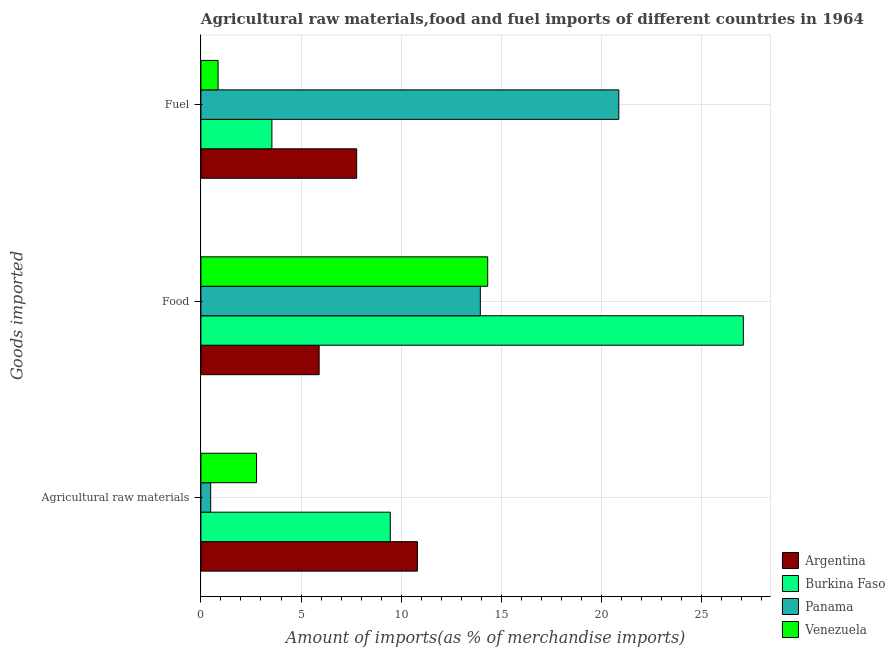How many different coloured bars are there?
Provide a succinct answer. 4. Are the number of bars on each tick of the Y-axis equal?
Your answer should be compact. Yes. What is the label of the 1st group of bars from the top?
Ensure brevity in your answer.  Fuel. What is the percentage of raw materials imports in Argentina?
Your answer should be compact. 10.81. Across all countries, what is the maximum percentage of raw materials imports?
Your answer should be very brief. 10.81. Across all countries, what is the minimum percentage of fuel imports?
Ensure brevity in your answer.  0.86. In which country was the percentage of fuel imports maximum?
Your answer should be very brief. Panama. In which country was the percentage of raw materials imports minimum?
Give a very brief answer. Panama. What is the total percentage of fuel imports in the graph?
Your answer should be compact. 33.06. What is the difference between the percentage of food imports in Panama and that in Burkina Faso?
Give a very brief answer. -13.14. What is the difference between the percentage of fuel imports in Panama and the percentage of raw materials imports in Venezuela?
Your response must be concise. 18.09. What is the average percentage of fuel imports per country?
Give a very brief answer. 8.26. What is the difference between the percentage of raw materials imports and percentage of fuel imports in Argentina?
Your answer should be compact. 3.03. In how many countries, is the percentage of raw materials imports greater than 5 %?
Make the answer very short. 2. What is the ratio of the percentage of raw materials imports in Venezuela to that in Panama?
Your response must be concise. 5.71. Is the difference between the percentage of raw materials imports in Burkina Faso and Venezuela greater than the difference between the percentage of fuel imports in Burkina Faso and Venezuela?
Make the answer very short. Yes. What is the difference between the highest and the second highest percentage of raw materials imports?
Your answer should be compact. 1.36. What is the difference between the highest and the lowest percentage of food imports?
Give a very brief answer. 21.19. In how many countries, is the percentage of food imports greater than the average percentage of food imports taken over all countries?
Offer a very short reply. 1. Is the sum of the percentage of fuel imports in Venezuela and Panama greater than the maximum percentage of food imports across all countries?
Provide a succinct answer. No. What does the 4th bar from the top in Agricultural raw materials represents?
Make the answer very short. Argentina. What does the 4th bar from the bottom in Fuel represents?
Provide a short and direct response. Venezuela. Are all the bars in the graph horizontal?
Offer a very short reply. Yes. Does the graph contain grids?
Keep it short and to the point. Yes. Where does the legend appear in the graph?
Your response must be concise. Bottom right. How many legend labels are there?
Offer a very short reply. 4. What is the title of the graph?
Your response must be concise. Agricultural raw materials,food and fuel imports of different countries in 1964. Does "Sierra Leone" appear as one of the legend labels in the graph?
Make the answer very short. No. What is the label or title of the X-axis?
Offer a terse response. Amount of imports(as % of merchandise imports). What is the label or title of the Y-axis?
Give a very brief answer. Goods imported. What is the Amount of imports(as % of merchandise imports) in Argentina in Agricultural raw materials?
Your answer should be very brief. 10.81. What is the Amount of imports(as % of merchandise imports) in Burkina Faso in Agricultural raw materials?
Your answer should be compact. 9.46. What is the Amount of imports(as % of merchandise imports) of Panama in Agricultural raw materials?
Your answer should be very brief. 0.49. What is the Amount of imports(as % of merchandise imports) in Venezuela in Agricultural raw materials?
Provide a succinct answer. 2.78. What is the Amount of imports(as % of merchandise imports) of Argentina in Food?
Offer a very short reply. 5.91. What is the Amount of imports(as % of merchandise imports) of Burkina Faso in Food?
Ensure brevity in your answer.  27.09. What is the Amount of imports(as % of merchandise imports) of Panama in Food?
Your answer should be compact. 13.96. What is the Amount of imports(as % of merchandise imports) in Venezuela in Food?
Make the answer very short. 14.32. What is the Amount of imports(as % of merchandise imports) in Argentina in Fuel?
Offer a terse response. 7.78. What is the Amount of imports(as % of merchandise imports) of Burkina Faso in Fuel?
Provide a short and direct response. 3.54. What is the Amount of imports(as % of merchandise imports) of Panama in Fuel?
Offer a very short reply. 20.87. What is the Amount of imports(as % of merchandise imports) of Venezuela in Fuel?
Your answer should be very brief. 0.86. Across all Goods imported, what is the maximum Amount of imports(as % of merchandise imports) in Argentina?
Offer a very short reply. 10.81. Across all Goods imported, what is the maximum Amount of imports(as % of merchandise imports) in Burkina Faso?
Your answer should be compact. 27.09. Across all Goods imported, what is the maximum Amount of imports(as % of merchandise imports) of Panama?
Your answer should be very brief. 20.87. Across all Goods imported, what is the maximum Amount of imports(as % of merchandise imports) of Venezuela?
Your response must be concise. 14.32. Across all Goods imported, what is the minimum Amount of imports(as % of merchandise imports) in Argentina?
Provide a succinct answer. 5.91. Across all Goods imported, what is the minimum Amount of imports(as % of merchandise imports) of Burkina Faso?
Make the answer very short. 3.54. Across all Goods imported, what is the minimum Amount of imports(as % of merchandise imports) in Panama?
Ensure brevity in your answer.  0.49. Across all Goods imported, what is the minimum Amount of imports(as % of merchandise imports) of Venezuela?
Your answer should be compact. 0.86. What is the total Amount of imports(as % of merchandise imports) of Argentina in the graph?
Keep it short and to the point. 24.5. What is the total Amount of imports(as % of merchandise imports) of Burkina Faso in the graph?
Provide a succinct answer. 40.09. What is the total Amount of imports(as % of merchandise imports) in Panama in the graph?
Make the answer very short. 35.32. What is the total Amount of imports(as % of merchandise imports) of Venezuela in the graph?
Your response must be concise. 17.96. What is the difference between the Amount of imports(as % of merchandise imports) in Argentina in Agricultural raw materials and that in Food?
Provide a short and direct response. 4.91. What is the difference between the Amount of imports(as % of merchandise imports) of Burkina Faso in Agricultural raw materials and that in Food?
Your answer should be very brief. -17.63. What is the difference between the Amount of imports(as % of merchandise imports) of Panama in Agricultural raw materials and that in Food?
Offer a terse response. -13.47. What is the difference between the Amount of imports(as % of merchandise imports) of Venezuela in Agricultural raw materials and that in Food?
Make the answer very short. -11.55. What is the difference between the Amount of imports(as % of merchandise imports) of Argentina in Agricultural raw materials and that in Fuel?
Give a very brief answer. 3.03. What is the difference between the Amount of imports(as % of merchandise imports) in Burkina Faso in Agricultural raw materials and that in Fuel?
Offer a very short reply. 5.91. What is the difference between the Amount of imports(as % of merchandise imports) of Panama in Agricultural raw materials and that in Fuel?
Keep it short and to the point. -20.39. What is the difference between the Amount of imports(as % of merchandise imports) of Venezuela in Agricultural raw materials and that in Fuel?
Your response must be concise. 1.92. What is the difference between the Amount of imports(as % of merchandise imports) in Argentina in Food and that in Fuel?
Ensure brevity in your answer.  -1.87. What is the difference between the Amount of imports(as % of merchandise imports) in Burkina Faso in Food and that in Fuel?
Make the answer very short. 23.55. What is the difference between the Amount of imports(as % of merchandise imports) in Panama in Food and that in Fuel?
Offer a very short reply. -6.92. What is the difference between the Amount of imports(as % of merchandise imports) in Venezuela in Food and that in Fuel?
Give a very brief answer. 13.47. What is the difference between the Amount of imports(as % of merchandise imports) in Argentina in Agricultural raw materials and the Amount of imports(as % of merchandise imports) in Burkina Faso in Food?
Your answer should be compact. -16.28. What is the difference between the Amount of imports(as % of merchandise imports) of Argentina in Agricultural raw materials and the Amount of imports(as % of merchandise imports) of Panama in Food?
Make the answer very short. -3.14. What is the difference between the Amount of imports(as % of merchandise imports) of Argentina in Agricultural raw materials and the Amount of imports(as % of merchandise imports) of Venezuela in Food?
Offer a terse response. -3.51. What is the difference between the Amount of imports(as % of merchandise imports) of Burkina Faso in Agricultural raw materials and the Amount of imports(as % of merchandise imports) of Panama in Food?
Make the answer very short. -4.5. What is the difference between the Amount of imports(as % of merchandise imports) in Burkina Faso in Agricultural raw materials and the Amount of imports(as % of merchandise imports) in Venezuela in Food?
Your answer should be very brief. -4.87. What is the difference between the Amount of imports(as % of merchandise imports) in Panama in Agricultural raw materials and the Amount of imports(as % of merchandise imports) in Venezuela in Food?
Your answer should be compact. -13.84. What is the difference between the Amount of imports(as % of merchandise imports) in Argentina in Agricultural raw materials and the Amount of imports(as % of merchandise imports) in Burkina Faso in Fuel?
Offer a terse response. 7.27. What is the difference between the Amount of imports(as % of merchandise imports) in Argentina in Agricultural raw materials and the Amount of imports(as % of merchandise imports) in Panama in Fuel?
Offer a very short reply. -10.06. What is the difference between the Amount of imports(as % of merchandise imports) of Argentina in Agricultural raw materials and the Amount of imports(as % of merchandise imports) of Venezuela in Fuel?
Keep it short and to the point. 9.95. What is the difference between the Amount of imports(as % of merchandise imports) in Burkina Faso in Agricultural raw materials and the Amount of imports(as % of merchandise imports) in Panama in Fuel?
Provide a short and direct response. -11.42. What is the difference between the Amount of imports(as % of merchandise imports) in Burkina Faso in Agricultural raw materials and the Amount of imports(as % of merchandise imports) in Venezuela in Fuel?
Your answer should be very brief. 8.6. What is the difference between the Amount of imports(as % of merchandise imports) of Panama in Agricultural raw materials and the Amount of imports(as % of merchandise imports) of Venezuela in Fuel?
Your answer should be very brief. -0.37. What is the difference between the Amount of imports(as % of merchandise imports) of Argentina in Food and the Amount of imports(as % of merchandise imports) of Burkina Faso in Fuel?
Offer a very short reply. 2.36. What is the difference between the Amount of imports(as % of merchandise imports) of Argentina in Food and the Amount of imports(as % of merchandise imports) of Panama in Fuel?
Offer a terse response. -14.97. What is the difference between the Amount of imports(as % of merchandise imports) in Argentina in Food and the Amount of imports(as % of merchandise imports) in Venezuela in Fuel?
Keep it short and to the point. 5.05. What is the difference between the Amount of imports(as % of merchandise imports) of Burkina Faso in Food and the Amount of imports(as % of merchandise imports) of Panama in Fuel?
Provide a short and direct response. 6.22. What is the difference between the Amount of imports(as % of merchandise imports) in Burkina Faso in Food and the Amount of imports(as % of merchandise imports) in Venezuela in Fuel?
Your answer should be very brief. 26.23. What is the difference between the Amount of imports(as % of merchandise imports) of Panama in Food and the Amount of imports(as % of merchandise imports) of Venezuela in Fuel?
Your response must be concise. 13.1. What is the average Amount of imports(as % of merchandise imports) of Argentina per Goods imported?
Your response must be concise. 8.17. What is the average Amount of imports(as % of merchandise imports) of Burkina Faso per Goods imported?
Give a very brief answer. 13.36. What is the average Amount of imports(as % of merchandise imports) of Panama per Goods imported?
Your response must be concise. 11.77. What is the average Amount of imports(as % of merchandise imports) in Venezuela per Goods imported?
Provide a short and direct response. 5.99. What is the difference between the Amount of imports(as % of merchandise imports) of Argentina and Amount of imports(as % of merchandise imports) of Burkina Faso in Agricultural raw materials?
Keep it short and to the point. 1.36. What is the difference between the Amount of imports(as % of merchandise imports) in Argentina and Amount of imports(as % of merchandise imports) in Panama in Agricultural raw materials?
Offer a very short reply. 10.33. What is the difference between the Amount of imports(as % of merchandise imports) in Argentina and Amount of imports(as % of merchandise imports) in Venezuela in Agricultural raw materials?
Give a very brief answer. 8.03. What is the difference between the Amount of imports(as % of merchandise imports) of Burkina Faso and Amount of imports(as % of merchandise imports) of Panama in Agricultural raw materials?
Give a very brief answer. 8.97. What is the difference between the Amount of imports(as % of merchandise imports) in Burkina Faso and Amount of imports(as % of merchandise imports) in Venezuela in Agricultural raw materials?
Ensure brevity in your answer.  6.68. What is the difference between the Amount of imports(as % of merchandise imports) of Panama and Amount of imports(as % of merchandise imports) of Venezuela in Agricultural raw materials?
Ensure brevity in your answer.  -2.29. What is the difference between the Amount of imports(as % of merchandise imports) in Argentina and Amount of imports(as % of merchandise imports) in Burkina Faso in Food?
Your answer should be compact. -21.19. What is the difference between the Amount of imports(as % of merchandise imports) in Argentina and Amount of imports(as % of merchandise imports) in Panama in Food?
Give a very brief answer. -8.05. What is the difference between the Amount of imports(as % of merchandise imports) in Argentina and Amount of imports(as % of merchandise imports) in Venezuela in Food?
Provide a short and direct response. -8.42. What is the difference between the Amount of imports(as % of merchandise imports) of Burkina Faso and Amount of imports(as % of merchandise imports) of Panama in Food?
Your answer should be compact. 13.14. What is the difference between the Amount of imports(as % of merchandise imports) in Burkina Faso and Amount of imports(as % of merchandise imports) in Venezuela in Food?
Make the answer very short. 12.77. What is the difference between the Amount of imports(as % of merchandise imports) in Panama and Amount of imports(as % of merchandise imports) in Venezuela in Food?
Ensure brevity in your answer.  -0.37. What is the difference between the Amount of imports(as % of merchandise imports) in Argentina and Amount of imports(as % of merchandise imports) in Burkina Faso in Fuel?
Provide a succinct answer. 4.24. What is the difference between the Amount of imports(as % of merchandise imports) of Argentina and Amount of imports(as % of merchandise imports) of Panama in Fuel?
Offer a very short reply. -13.09. What is the difference between the Amount of imports(as % of merchandise imports) of Argentina and Amount of imports(as % of merchandise imports) of Venezuela in Fuel?
Your response must be concise. 6.92. What is the difference between the Amount of imports(as % of merchandise imports) in Burkina Faso and Amount of imports(as % of merchandise imports) in Panama in Fuel?
Give a very brief answer. -17.33. What is the difference between the Amount of imports(as % of merchandise imports) of Burkina Faso and Amount of imports(as % of merchandise imports) of Venezuela in Fuel?
Offer a very short reply. 2.69. What is the difference between the Amount of imports(as % of merchandise imports) of Panama and Amount of imports(as % of merchandise imports) of Venezuela in Fuel?
Offer a terse response. 20.01. What is the ratio of the Amount of imports(as % of merchandise imports) in Argentina in Agricultural raw materials to that in Food?
Keep it short and to the point. 1.83. What is the ratio of the Amount of imports(as % of merchandise imports) in Burkina Faso in Agricultural raw materials to that in Food?
Your response must be concise. 0.35. What is the ratio of the Amount of imports(as % of merchandise imports) of Panama in Agricultural raw materials to that in Food?
Offer a terse response. 0.03. What is the ratio of the Amount of imports(as % of merchandise imports) of Venezuela in Agricultural raw materials to that in Food?
Offer a terse response. 0.19. What is the ratio of the Amount of imports(as % of merchandise imports) of Argentina in Agricultural raw materials to that in Fuel?
Make the answer very short. 1.39. What is the ratio of the Amount of imports(as % of merchandise imports) of Burkina Faso in Agricultural raw materials to that in Fuel?
Your answer should be very brief. 2.67. What is the ratio of the Amount of imports(as % of merchandise imports) in Panama in Agricultural raw materials to that in Fuel?
Your response must be concise. 0.02. What is the ratio of the Amount of imports(as % of merchandise imports) of Venezuela in Agricultural raw materials to that in Fuel?
Your answer should be compact. 3.24. What is the ratio of the Amount of imports(as % of merchandise imports) of Argentina in Food to that in Fuel?
Make the answer very short. 0.76. What is the ratio of the Amount of imports(as % of merchandise imports) in Burkina Faso in Food to that in Fuel?
Give a very brief answer. 7.64. What is the ratio of the Amount of imports(as % of merchandise imports) in Panama in Food to that in Fuel?
Your response must be concise. 0.67. What is the ratio of the Amount of imports(as % of merchandise imports) in Venezuela in Food to that in Fuel?
Keep it short and to the point. 16.68. What is the difference between the highest and the second highest Amount of imports(as % of merchandise imports) of Argentina?
Give a very brief answer. 3.03. What is the difference between the highest and the second highest Amount of imports(as % of merchandise imports) of Burkina Faso?
Your response must be concise. 17.63. What is the difference between the highest and the second highest Amount of imports(as % of merchandise imports) of Panama?
Your response must be concise. 6.92. What is the difference between the highest and the second highest Amount of imports(as % of merchandise imports) of Venezuela?
Your answer should be very brief. 11.55. What is the difference between the highest and the lowest Amount of imports(as % of merchandise imports) in Argentina?
Offer a very short reply. 4.91. What is the difference between the highest and the lowest Amount of imports(as % of merchandise imports) of Burkina Faso?
Your response must be concise. 23.55. What is the difference between the highest and the lowest Amount of imports(as % of merchandise imports) of Panama?
Keep it short and to the point. 20.39. What is the difference between the highest and the lowest Amount of imports(as % of merchandise imports) in Venezuela?
Offer a very short reply. 13.47. 